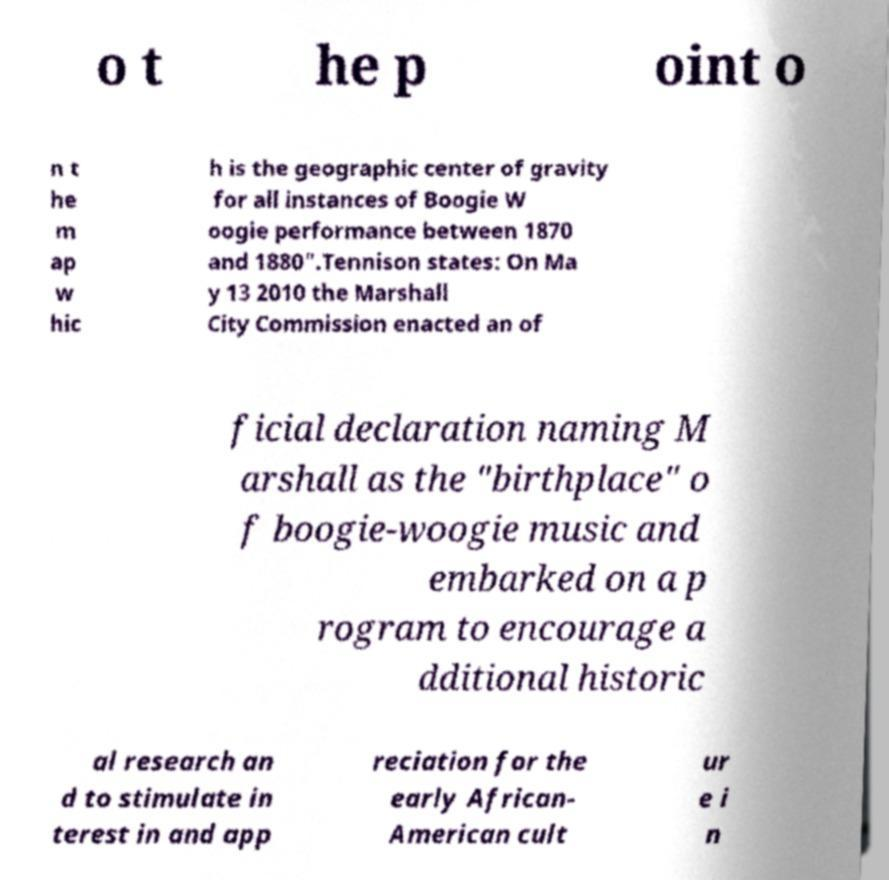I need the written content from this picture converted into text. Can you do that? o t he p oint o n t he m ap w hic h is the geographic center of gravity for all instances of Boogie W oogie performance between 1870 and 1880".Tennison states: On Ma y 13 2010 the Marshall City Commission enacted an of ficial declaration naming M arshall as the "birthplace" o f boogie-woogie music and embarked on a p rogram to encourage a dditional historic al research an d to stimulate in terest in and app reciation for the early African- American cult ur e i n 